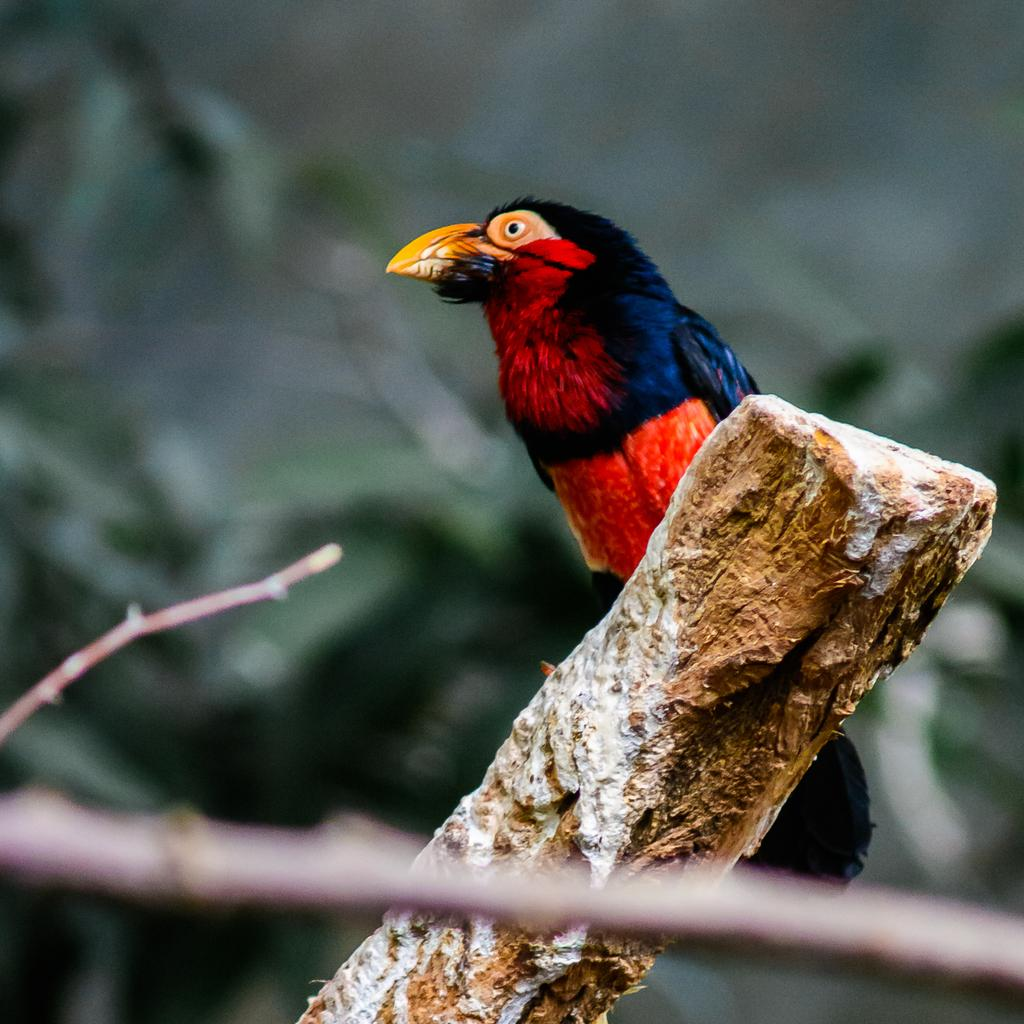What type of animal is in the image? There is a bird in the image. What is the bird perched on? The bird is on a wooden stick. Can you describe the small object at the bottom of the image? There is a small wooden stick at the bottom of the image. What can be seen in the background of the image? There are trees in the background of the image. What type of books can be seen on the bird's back in the image? There are no books present in the image, and the bird's back is not visible. 